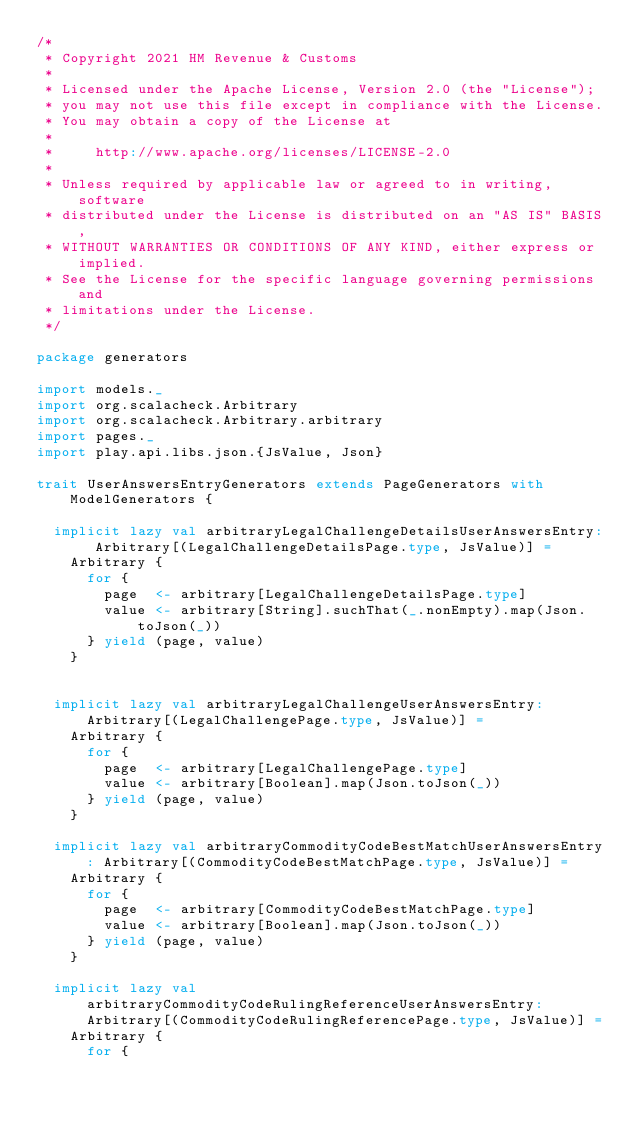Convert code to text. <code><loc_0><loc_0><loc_500><loc_500><_Scala_>/*
 * Copyright 2021 HM Revenue & Customs
 *
 * Licensed under the Apache License, Version 2.0 (the "License");
 * you may not use this file except in compliance with the License.
 * You may obtain a copy of the License at
 *
 *     http://www.apache.org/licenses/LICENSE-2.0
 *
 * Unless required by applicable law or agreed to in writing, software
 * distributed under the License is distributed on an "AS IS" BASIS,
 * WITHOUT WARRANTIES OR CONDITIONS OF ANY KIND, either express or implied.
 * See the License for the specific language governing permissions and
 * limitations under the License.
 */

package generators

import models._
import org.scalacheck.Arbitrary
import org.scalacheck.Arbitrary.arbitrary
import pages._
import play.api.libs.json.{JsValue, Json}

trait UserAnswersEntryGenerators extends PageGenerators with ModelGenerators {

  implicit lazy val arbitraryLegalChallengeDetailsUserAnswersEntry: Arbitrary[(LegalChallengeDetailsPage.type, JsValue)] =
    Arbitrary {
      for {
        page  <- arbitrary[LegalChallengeDetailsPage.type]
        value <- arbitrary[String].suchThat(_.nonEmpty).map(Json.toJson(_))
      } yield (page, value)
    }


  implicit lazy val arbitraryLegalChallengeUserAnswersEntry: Arbitrary[(LegalChallengePage.type, JsValue)] =
    Arbitrary {
      for {
        page  <- arbitrary[LegalChallengePage.type]
        value <- arbitrary[Boolean].map(Json.toJson(_))
      } yield (page, value)
    }

  implicit lazy val arbitraryCommodityCodeBestMatchUserAnswersEntry: Arbitrary[(CommodityCodeBestMatchPage.type, JsValue)] =
    Arbitrary {
      for {
        page  <- arbitrary[CommodityCodeBestMatchPage.type]
        value <- arbitrary[Boolean].map(Json.toJson(_))
      } yield (page, value)
    }

  implicit lazy val arbitraryCommodityCodeRulingReferenceUserAnswersEntry: Arbitrary[(CommodityCodeRulingReferencePage.type, JsValue)] =
    Arbitrary {
      for {</code> 